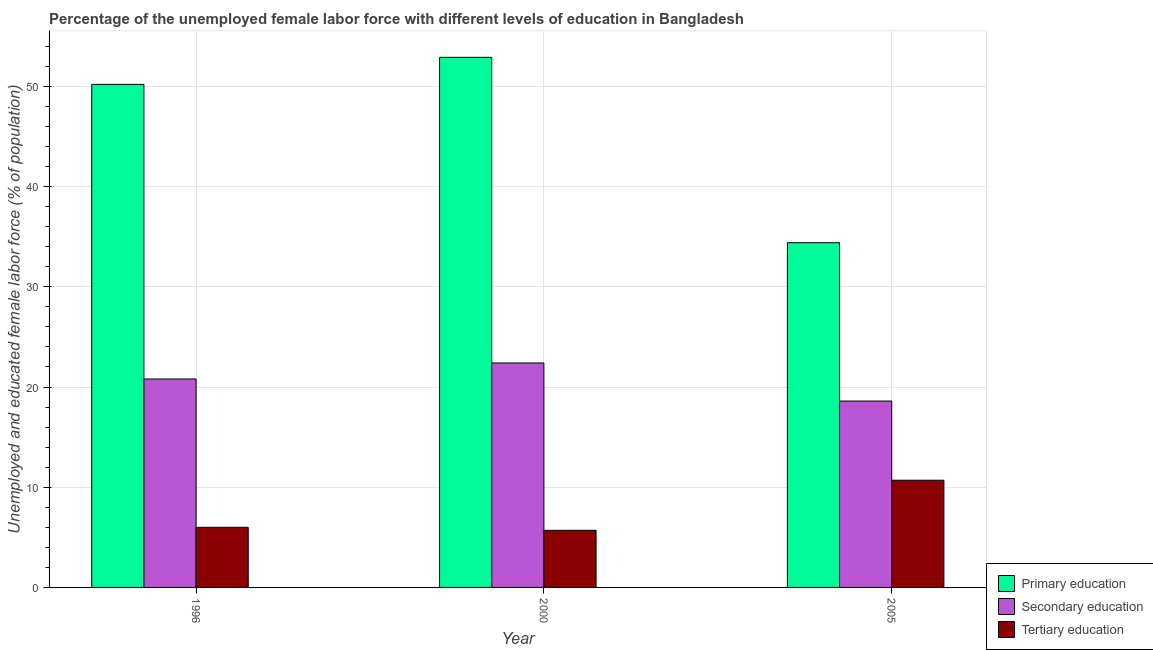How many different coloured bars are there?
Ensure brevity in your answer.  3. How many groups of bars are there?
Give a very brief answer. 3. Are the number of bars on each tick of the X-axis equal?
Offer a very short reply. Yes. What is the label of the 1st group of bars from the left?
Keep it short and to the point. 1996. In how many cases, is the number of bars for a given year not equal to the number of legend labels?
Your answer should be compact. 0. What is the percentage of female labor force who received primary education in 1996?
Offer a very short reply. 50.2. Across all years, what is the maximum percentage of female labor force who received primary education?
Offer a very short reply. 52.9. Across all years, what is the minimum percentage of female labor force who received primary education?
Give a very brief answer. 34.4. In which year was the percentage of female labor force who received tertiary education maximum?
Your response must be concise. 2005. In which year was the percentage of female labor force who received primary education minimum?
Provide a short and direct response. 2005. What is the total percentage of female labor force who received tertiary education in the graph?
Offer a terse response. 22.4. What is the difference between the percentage of female labor force who received secondary education in 2000 and the percentage of female labor force who received tertiary education in 1996?
Provide a succinct answer. 1.6. What is the average percentage of female labor force who received secondary education per year?
Ensure brevity in your answer.  20.6. In the year 1996, what is the difference between the percentage of female labor force who received primary education and percentage of female labor force who received secondary education?
Offer a very short reply. 0. In how many years, is the percentage of female labor force who received primary education greater than 46 %?
Provide a short and direct response. 2. What is the ratio of the percentage of female labor force who received primary education in 1996 to that in 2000?
Give a very brief answer. 0.95. Is the percentage of female labor force who received primary education in 1996 less than that in 2000?
Your response must be concise. Yes. Is the difference between the percentage of female labor force who received tertiary education in 2000 and 2005 greater than the difference between the percentage of female labor force who received primary education in 2000 and 2005?
Provide a short and direct response. No. What is the difference between the highest and the second highest percentage of female labor force who received tertiary education?
Your response must be concise. 4.7. In how many years, is the percentage of female labor force who received tertiary education greater than the average percentage of female labor force who received tertiary education taken over all years?
Ensure brevity in your answer.  1. What does the 1st bar from the left in 2000 represents?
Give a very brief answer. Primary education. Is it the case that in every year, the sum of the percentage of female labor force who received primary education and percentage of female labor force who received secondary education is greater than the percentage of female labor force who received tertiary education?
Make the answer very short. Yes. How many bars are there?
Your answer should be very brief. 9. What is the difference between two consecutive major ticks on the Y-axis?
Offer a very short reply. 10. Does the graph contain grids?
Provide a short and direct response. Yes. Where does the legend appear in the graph?
Keep it short and to the point. Bottom right. How are the legend labels stacked?
Your answer should be compact. Vertical. What is the title of the graph?
Keep it short and to the point. Percentage of the unemployed female labor force with different levels of education in Bangladesh. What is the label or title of the X-axis?
Keep it short and to the point. Year. What is the label or title of the Y-axis?
Your response must be concise. Unemployed and educated female labor force (% of population). What is the Unemployed and educated female labor force (% of population) of Primary education in 1996?
Your answer should be very brief. 50.2. What is the Unemployed and educated female labor force (% of population) in Secondary education in 1996?
Offer a terse response. 20.8. What is the Unemployed and educated female labor force (% of population) in Primary education in 2000?
Ensure brevity in your answer.  52.9. What is the Unemployed and educated female labor force (% of population) of Secondary education in 2000?
Your answer should be very brief. 22.4. What is the Unemployed and educated female labor force (% of population) of Tertiary education in 2000?
Your answer should be very brief. 5.7. What is the Unemployed and educated female labor force (% of population) of Primary education in 2005?
Offer a very short reply. 34.4. What is the Unemployed and educated female labor force (% of population) of Secondary education in 2005?
Your response must be concise. 18.6. What is the Unemployed and educated female labor force (% of population) in Tertiary education in 2005?
Offer a very short reply. 10.7. Across all years, what is the maximum Unemployed and educated female labor force (% of population) in Primary education?
Your answer should be very brief. 52.9. Across all years, what is the maximum Unemployed and educated female labor force (% of population) of Secondary education?
Your response must be concise. 22.4. Across all years, what is the maximum Unemployed and educated female labor force (% of population) in Tertiary education?
Provide a short and direct response. 10.7. Across all years, what is the minimum Unemployed and educated female labor force (% of population) in Primary education?
Your answer should be very brief. 34.4. Across all years, what is the minimum Unemployed and educated female labor force (% of population) of Secondary education?
Your answer should be compact. 18.6. Across all years, what is the minimum Unemployed and educated female labor force (% of population) of Tertiary education?
Your answer should be compact. 5.7. What is the total Unemployed and educated female labor force (% of population) in Primary education in the graph?
Your answer should be very brief. 137.5. What is the total Unemployed and educated female labor force (% of population) of Secondary education in the graph?
Make the answer very short. 61.8. What is the total Unemployed and educated female labor force (% of population) in Tertiary education in the graph?
Your answer should be very brief. 22.4. What is the difference between the Unemployed and educated female labor force (% of population) in Primary education in 1996 and that in 2000?
Give a very brief answer. -2.7. What is the difference between the Unemployed and educated female labor force (% of population) in Secondary education in 1996 and that in 2000?
Keep it short and to the point. -1.6. What is the difference between the Unemployed and educated female labor force (% of population) in Tertiary education in 1996 and that in 2000?
Your answer should be compact. 0.3. What is the difference between the Unemployed and educated female labor force (% of population) in Primary education in 1996 and that in 2005?
Your answer should be very brief. 15.8. What is the difference between the Unemployed and educated female labor force (% of population) of Secondary education in 1996 and that in 2005?
Your answer should be very brief. 2.2. What is the difference between the Unemployed and educated female labor force (% of population) of Primary education in 2000 and that in 2005?
Keep it short and to the point. 18.5. What is the difference between the Unemployed and educated female labor force (% of population) of Primary education in 1996 and the Unemployed and educated female labor force (% of population) of Secondary education in 2000?
Provide a short and direct response. 27.8. What is the difference between the Unemployed and educated female labor force (% of population) in Primary education in 1996 and the Unemployed and educated female labor force (% of population) in Tertiary education in 2000?
Ensure brevity in your answer.  44.5. What is the difference between the Unemployed and educated female labor force (% of population) of Secondary education in 1996 and the Unemployed and educated female labor force (% of population) of Tertiary education in 2000?
Your answer should be compact. 15.1. What is the difference between the Unemployed and educated female labor force (% of population) of Primary education in 1996 and the Unemployed and educated female labor force (% of population) of Secondary education in 2005?
Keep it short and to the point. 31.6. What is the difference between the Unemployed and educated female labor force (% of population) in Primary education in 1996 and the Unemployed and educated female labor force (% of population) in Tertiary education in 2005?
Offer a very short reply. 39.5. What is the difference between the Unemployed and educated female labor force (% of population) in Secondary education in 1996 and the Unemployed and educated female labor force (% of population) in Tertiary education in 2005?
Keep it short and to the point. 10.1. What is the difference between the Unemployed and educated female labor force (% of population) in Primary education in 2000 and the Unemployed and educated female labor force (% of population) in Secondary education in 2005?
Offer a terse response. 34.3. What is the difference between the Unemployed and educated female labor force (% of population) in Primary education in 2000 and the Unemployed and educated female labor force (% of population) in Tertiary education in 2005?
Offer a terse response. 42.2. What is the difference between the Unemployed and educated female labor force (% of population) in Secondary education in 2000 and the Unemployed and educated female labor force (% of population) in Tertiary education in 2005?
Your response must be concise. 11.7. What is the average Unemployed and educated female labor force (% of population) in Primary education per year?
Make the answer very short. 45.83. What is the average Unemployed and educated female labor force (% of population) in Secondary education per year?
Keep it short and to the point. 20.6. What is the average Unemployed and educated female labor force (% of population) in Tertiary education per year?
Give a very brief answer. 7.47. In the year 1996, what is the difference between the Unemployed and educated female labor force (% of population) in Primary education and Unemployed and educated female labor force (% of population) in Secondary education?
Provide a short and direct response. 29.4. In the year 1996, what is the difference between the Unemployed and educated female labor force (% of population) in Primary education and Unemployed and educated female labor force (% of population) in Tertiary education?
Provide a succinct answer. 44.2. In the year 1996, what is the difference between the Unemployed and educated female labor force (% of population) of Secondary education and Unemployed and educated female labor force (% of population) of Tertiary education?
Offer a very short reply. 14.8. In the year 2000, what is the difference between the Unemployed and educated female labor force (% of population) in Primary education and Unemployed and educated female labor force (% of population) in Secondary education?
Make the answer very short. 30.5. In the year 2000, what is the difference between the Unemployed and educated female labor force (% of population) in Primary education and Unemployed and educated female labor force (% of population) in Tertiary education?
Provide a short and direct response. 47.2. In the year 2000, what is the difference between the Unemployed and educated female labor force (% of population) of Secondary education and Unemployed and educated female labor force (% of population) of Tertiary education?
Offer a terse response. 16.7. In the year 2005, what is the difference between the Unemployed and educated female labor force (% of population) in Primary education and Unemployed and educated female labor force (% of population) in Tertiary education?
Offer a very short reply. 23.7. What is the ratio of the Unemployed and educated female labor force (% of population) of Primary education in 1996 to that in 2000?
Your response must be concise. 0.95. What is the ratio of the Unemployed and educated female labor force (% of population) of Tertiary education in 1996 to that in 2000?
Your answer should be compact. 1.05. What is the ratio of the Unemployed and educated female labor force (% of population) in Primary education in 1996 to that in 2005?
Your response must be concise. 1.46. What is the ratio of the Unemployed and educated female labor force (% of population) in Secondary education in 1996 to that in 2005?
Offer a terse response. 1.12. What is the ratio of the Unemployed and educated female labor force (% of population) of Tertiary education in 1996 to that in 2005?
Offer a very short reply. 0.56. What is the ratio of the Unemployed and educated female labor force (% of population) in Primary education in 2000 to that in 2005?
Keep it short and to the point. 1.54. What is the ratio of the Unemployed and educated female labor force (% of population) of Secondary education in 2000 to that in 2005?
Your response must be concise. 1.2. What is the ratio of the Unemployed and educated female labor force (% of population) in Tertiary education in 2000 to that in 2005?
Provide a short and direct response. 0.53. What is the difference between the highest and the second highest Unemployed and educated female labor force (% of population) of Secondary education?
Keep it short and to the point. 1.6. What is the difference between the highest and the lowest Unemployed and educated female labor force (% of population) of Primary education?
Offer a terse response. 18.5. 